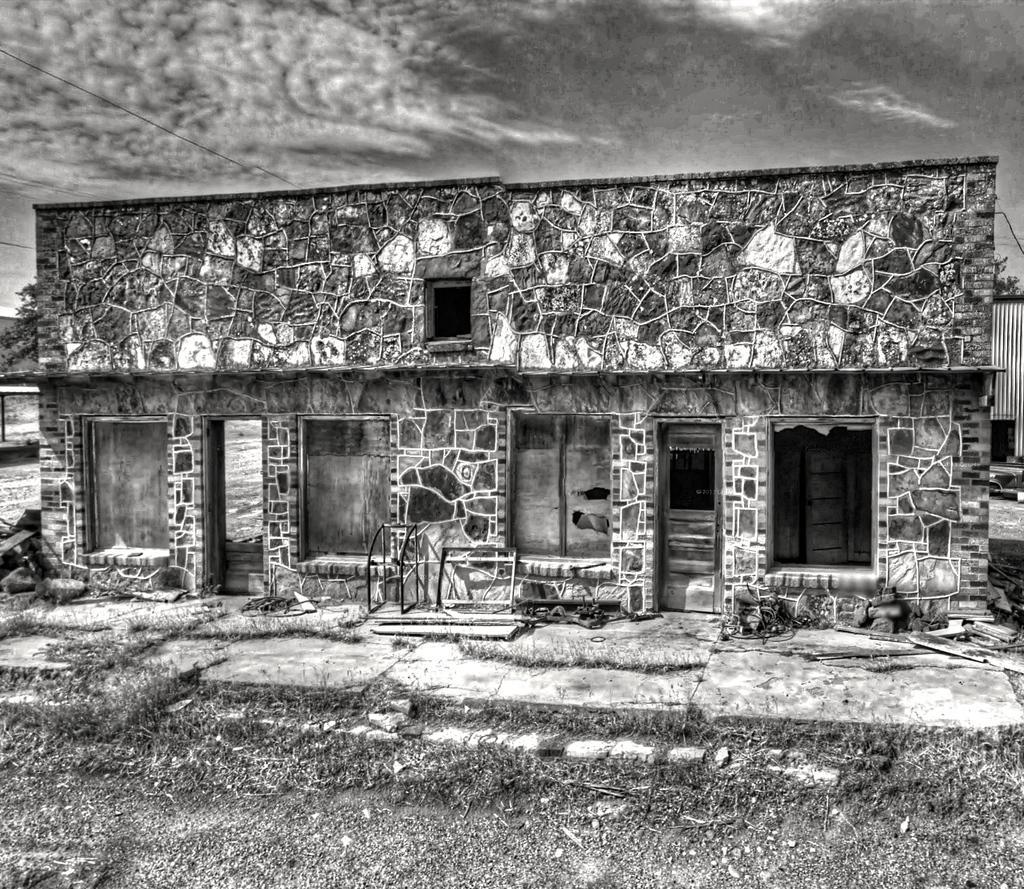Can you describe this image briefly? In this image we can see a building. On the ground there is grass. In the background there is sky with clouds. And this is a black and white image. 